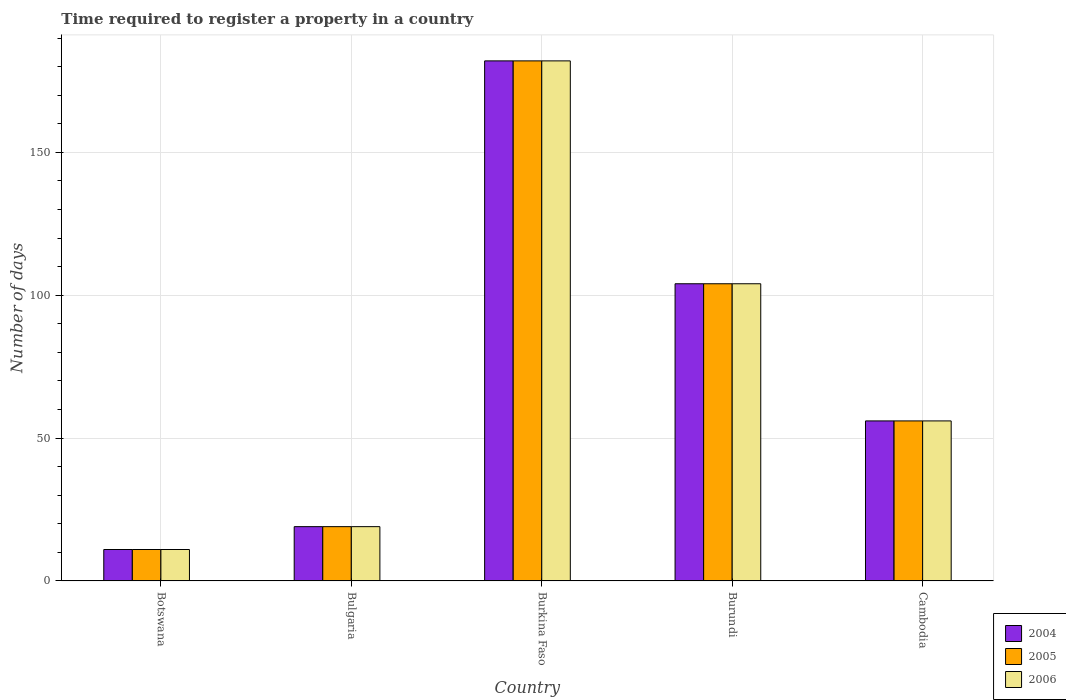Are the number of bars per tick equal to the number of legend labels?
Your response must be concise. Yes. How many bars are there on the 5th tick from the left?
Keep it short and to the point. 3. How many bars are there on the 5th tick from the right?
Ensure brevity in your answer.  3. In how many cases, is the number of bars for a given country not equal to the number of legend labels?
Your answer should be compact. 0. Across all countries, what is the maximum number of days required to register a property in 2004?
Offer a terse response. 182. Across all countries, what is the minimum number of days required to register a property in 2005?
Give a very brief answer. 11. In which country was the number of days required to register a property in 2006 maximum?
Provide a short and direct response. Burkina Faso. In which country was the number of days required to register a property in 2004 minimum?
Ensure brevity in your answer.  Botswana. What is the total number of days required to register a property in 2005 in the graph?
Give a very brief answer. 372. What is the difference between the number of days required to register a property in 2005 in Botswana and that in Burkina Faso?
Provide a succinct answer. -171. What is the difference between the number of days required to register a property in 2006 in Burkina Faso and the number of days required to register a property in 2004 in Botswana?
Give a very brief answer. 171. What is the average number of days required to register a property in 2005 per country?
Provide a succinct answer. 74.4. What is the ratio of the number of days required to register a property in 2006 in Botswana to that in Burkina Faso?
Give a very brief answer. 0.06. Is the difference between the number of days required to register a property in 2005 in Burundi and Cambodia greater than the difference between the number of days required to register a property in 2004 in Burundi and Cambodia?
Your response must be concise. No. What is the difference between the highest and the second highest number of days required to register a property in 2006?
Offer a terse response. 48. What is the difference between the highest and the lowest number of days required to register a property in 2004?
Provide a short and direct response. 171. In how many countries, is the number of days required to register a property in 2006 greater than the average number of days required to register a property in 2006 taken over all countries?
Keep it short and to the point. 2. What does the 3rd bar from the left in Botswana represents?
Keep it short and to the point. 2006. How many bars are there?
Offer a very short reply. 15. How many countries are there in the graph?
Give a very brief answer. 5. What is the difference between two consecutive major ticks on the Y-axis?
Your response must be concise. 50. Are the values on the major ticks of Y-axis written in scientific E-notation?
Offer a terse response. No. Does the graph contain any zero values?
Your response must be concise. No. Where does the legend appear in the graph?
Offer a terse response. Bottom right. How are the legend labels stacked?
Provide a succinct answer. Vertical. What is the title of the graph?
Keep it short and to the point. Time required to register a property in a country. Does "1975" appear as one of the legend labels in the graph?
Make the answer very short. No. What is the label or title of the X-axis?
Make the answer very short. Country. What is the label or title of the Y-axis?
Offer a terse response. Number of days. What is the Number of days of 2004 in Botswana?
Your answer should be compact. 11. What is the Number of days in 2006 in Botswana?
Provide a short and direct response. 11. What is the Number of days of 2004 in Bulgaria?
Provide a short and direct response. 19. What is the Number of days of 2005 in Bulgaria?
Make the answer very short. 19. What is the Number of days in 2004 in Burkina Faso?
Ensure brevity in your answer.  182. What is the Number of days of 2005 in Burkina Faso?
Keep it short and to the point. 182. What is the Number of days of 2006 in Burkina Faso?
Offer a very short reply. 182. What is the Number of days in 2004 in Burundi?
Provide a succinct answer. 104. What is the Number of days of 2005 in Burundi?
Offer a terse response. 104. What is the Number of days in 2006 in Burundi?
Your answer should be compact. 104. What is the Number of days of 2005 in Cambodia?
Keep it short and to the point. 56. What is the Number of days in 2006 in Cambodia?
Your answer should be very brief. 56. Across all countries, what is the maximum Number of days in 2004?
Keep it short and to the point. 182. Across all countries, what is the maximum Number of days in 2005?
Provide a short and direct response. 182. Across all countries, what is the maximum Number of days of 2006?
Your response must be concise. 182. Across all countries, what is the minimum Number of days in 2004?
Give a very brief answer. 11. Across all countries, what is the minimum Number of days in 2006?
Provide a short and direct response. 11. What is the total Number of days of 2004 in the graph?
Offer a very short reply. 372. What is the total Number of days in 2005 in the graph?
Provide a succinct answer. 372. What is the total Number of days of 2006 in the graph?
Make the answer very short. 372. What is the difference between the Number of days in 2004 in Botswana and that in Bulgaria?
Provide a succinct answer. -8. What is the difference between the Number of days of 2005 in Botswana and that in Bulgaria?
Your answer should be very brief. -8. What is the difference between the Number of days in 2006 in Botswana and that in Bulgaria?
Your answer should be very brief. -8. What is the difference between the Number of days in 2004 in Botswana and that in Burkina Faso?
Make the answer very short. -171. What is the difference between the Number of days in 2005 in Botswana and that in Burkina Faso?
Your response must be concise. -171. What is the difference between the Number of days of 2006 in Botswana and that in Burkina Faso?
Your response must be concise. -171. What is the difference between the Number of days of 2004 in Botswana and that in Burundi?
Offer a very short reply. -93. What is the difference between the Number of days in 2005 in Botswana and that in Burundi?
Your answer should be compact. -93. What is the difference between the Number of days of 2006 in Botswana and that in Burundi?
Offer a terse response. -93. What is the difference between the Number of days of 2004 in Botswana and that in Cambodia?
Offer a terse response. -45. What is the difference between the Number of days of 2005 in Botswana and that in Cambodia?
Your response must be concise. -45. What is the difference between the Number of days in 2006 in Botswana and that in Cambodia?
Provide a succinct answer. -45. What is the difference between the Number of days in 2004 in Bulgaria and that in Burkina Faso?
Ensure brevity in your answer.  -163. What is the difference between the Number of days of 2005 in Bulgaria and that in Burkina Faso?
Your answer should be very brief. -163. What is the difference between the Number of days of 2006 in Bulgaria and that in Burkina Faso?
Ensure brevity in your answer.  -163. What is the difference between the Number of days in 2004 in Bulgaria and that in Burundi?
Provide a short and direct response. -85. What is the difference between the Number of days of 2005 in Bulgaria and that in Burundi?
Your answer should be compact. -85. What is the difference between the Number of days of 2006 in Bulgaria and that in Burundi?
Keep it short and to the point. -85. What is the difference between the Number of days of 2004 in Bulgaria and that in Cambodia?
Your answer should be very brief. -37. What is the difference between the Number of days of 2005 in Bulgaria and that in Cambodia?
Offer a very short reply. -37. What is the difference between the Number of days of 2006 in Bulgaria and that in Cambodia?
Give a very brief answer. -37. What is the difference between the Number of days of 2004 in Burkina Faso and that in Burundi?
Keep it short and to the point. 78. What is the difference between the Number of days in 2005 in Burkina Faso and that in Burundi?
Your response must be concise. 78. What is the difference between the Number of days in 2004 in Burkina Faso and that in Cambodia?
Offer a very short reply. 126. What is the difference between the Number of days of 2005 in Burkina Faso and that in Cambodia?
Keep it short and to the point. 126. What is the difference between the Number of days of 2006 in Burkina Faso and that in Cambodia?
Provide a succinct answer. 126. What is the difference between the Number of days in 2005 in Burundi and that in Cambodia?
Offer a terse response. 48. What is the difference between the Number of days of 2004 in Botswana and the Number of days of 2006 in Bulgaria?
Ensure brevity in your answer.  -8. What is the difference between the Number of days of 2005 in Botswana and the Number of days of 2006 in Bulgaria?
Keep it short and to the point. -8. What is the difference between the Number of days in 2004 in Botswana and the Number of days in 2005 in Burkina Faso?
Offer a terse response. -171. What is the difference between the Number of days in 2004 in Botswana and the Number of days in 2006 in Burkina Faso?
Your response must be concise. -171. What is the difference between the Number of days of 2005 in Botswana and the Number of days of 2006 in Burkina Faso?
Offer a terse response. -171. What is the difference between the Number of days in 2004 in Botswana and the Number of days in 2005 in Burundi?
Your answer should be very brief. -93. What is the difference between the Number of days in 2004 in Botswana and the Number of days in 2006 in Burundi?
Give a very brief answer. -93. What is the difference between the Number of days of 2005 in Botswana and the Number of days of 2006 in Burundi?
Give a very brief answer. -93. What is the difference between the Number of days of 2004 in Botswana and the Number of days of 2005 in Cambodia?
Keep it short and to the point. -45. What is the difference between the Number of days in 2004 in Botswana and the Number of days in 2006 in Cambodia?
Your response must be concise. -45. What is the difference between the Number of days in 2005 in Botswana and the Number of days in 2006 in Cambodia?
Your answer should be compact. -45. What is the difference between the Number of days in 2004 in Bulgaria and the Number of days in 2005 in Burkina Faso?
Ensure brevity in your answer.  -163. What is the difference between the Number of days in 2004 in Bulgaria and the Number of days in 2006 in Burkina Faso?
Give a very brief answer. -163. What is the difference between the Number of days of 2005 in Bulgaria and the Number of days of 2006 in Burkina Faso?
Offer a very short reply. -163. What is the difference between the Number of days of 2004 in Bulgaria and the Number of days of 2005 in Burundi?
Provide a short and direct response. -85. What is the difference between the Number of days in 2004 in Bulgaria and the Number of days in 2006 in Burundi?
Your answer should be very brief. -85. What is the difference between the Number of days in 2005 in Bulgaria and the Number of days in 2006 in Burundi?
Make the answer very short. -85. What is the difference between the Number of days of 2004 in Bulgaria and the Number of days of 2005 in Cambodia?
Your answer should be compact. -37. What is the difference between the Number of days of 2004 in Bulgaria and the Number of days of 2006 in Cambodia?
Provide a succinct answer. -37. What is the difference between the Number of days of 2005 in Bulgaria and the Number of days of 2006 in Cambodia?
Provide a short and direct response. -37. What is the difference between the Number of days of 2004 in Burkina Faso and the Number of days of 2006 in Burundi?
Provide a succinct answer. 78. What is the difference between the Number of days of 2004 in Burkina Faso and the Number of days of 2005 in Cambodia?
Offer a very short reply. 126. What is the difference between the Number of days in 2004 in Burkina Faso and the Number of days in 2006 in Cambodia?
Give a very brief answer. 126. What is the difference between the Number of days of 2005 in Burkina Faso and the Number of days of 2006 in Cambodia?
Provide a succinct answer. 126. What is the difference between the Number of days of 2005 in Burundi and the Number of days of 2006 in Cambodia?
Offer a very short reply. 48. What is the average Number of days of 2004 per country?
Provide a succinct answer. 74.4. What is the average Number of days in 2005 per country?
Your answer should be compact. 74.4. What is the average Number of days of 2006 per country?
Provide a short and direct response. 74.4. What is the difference between the Number of days of 2004 and Number of days of 2005 in Botswana?
Provide a short and direct response. 0. What is the difference between the Number of days in 2005 and Number of days in 2006 in Botswana?
Your answer should be very brief. 0. What is the difference between the Number of days of 2004 and Number of days of 2005 in Bulgaria?
Your answer should be very brief. 0. What is the difference between the Number of days of 2004 and Number of days of 2006 in Bulgaria?
Offer a terse response. 0. What is the difference between the Number of days of 2004 and Number of days of 2005 in Burkina Faso?
Offer a very short reply. 0. What is the difference between the Number of days of 2004 and Number of days of 2006 in Burkina Faso?
Make the answer very short. 0. What is the difference between the Number of days in 2005 and Number of days in 2006 in Burkina Faso?
Offer a very short reply. 0. What is the difference between the Number of days of 2004 and Number of days of 2005 in Burundi?
Provide a succinct answer. 0. What is the difference between the Number of days in 2004 and Number of days in 2006 in Burundi?
Offer a terse response. 0. What is the difference between the Number of days in 2005 and Number of days in 2006 in Burundi?
Provide a short and direct response. 0. What is the difference between the Number of days in 2004 and Number of days in 2006 in Cambodia?
Ensure brevity in your answer.  0. What is the difference between the Number of days of 2005 and Number of days of 2006 in Cambodia?
Provide a short and direct response. 0. What is the ratio of the Number of days of 2004 in Botswana to that in Bulgaria?
Provide a short and direct response. 0.58. What is the ratio of the Number of days in 2005 in Botswana to that in Bulgaria?
Provide a succinct answer. 0.58. What is the ratio of the Number of days of 2006 in Botswana to that in Bulgaria?
Offer a terse response. 0.58. What is the ratio of the Number of days of 2004 in Botswana to that in Burkina Faso?
Give a very brief answer. 0.06. What is the ratio of the Number of days in 2005 in Botswana to that in Burkina Faso?
Ensure brevity in your answer.  0.06. What is the ratio of the Number of days in 2006 in Botswana to that in Burkina Faso?
Offer a terse response. 0.06. What is the ratio of the Number of days in 2004 in Botswana to that in Burundi?
Give a very brief answer. 0.11. What is the ratio of the Number of days in 2005 in Botswana to that in Burundi?
Provide a short and direct response. 0.11. What is the ratio of the Number of days of 2006 in Botswana to that in Burundi?
Offer a terse response. 0.11. What is the ratio of the Number of days in 2004 in Botswana to that in Cambodia?
Make the answer very short. 0.2. What is the ratio of the Number of days in 2005 in Botswana to that in Cambodia?
Ensure brevity in your answer.  0.2. What is the ratio of the Number of days of 2006 in Botswana to that in Cambodia?
Make the answer very short. 0.2. What is the ratio of the Number of days of 2004 in Bulgaria to that in Burkina Faso?
Your answer should be very brief. 0.1. What is the ratio of the Number of days of 2005 in Bulgaria to that in Burkina Faso?
Ensure brevity in your answer.  0.1. What is the ratio of the Number of days of 2006 in Bulgaria to that in Burkina Faso?
Ensure brevity in your answer.  0.1. What is the ratio of the Number of days of 2004 in Bulgaria to that in Burundi?
Provide a short and direct response. 0.18. What is the ratio of the Number of days in 2005 in Bulgaria to that in Burundi?
Offer a very short reply. 0.18. What is the ratio of the Number of days in 2006 in Bulgaria to that in Burundi?
Ensure brevity in your answer.  0.18. What is the ratio of the Number of days in 2004 in Bulgaria to that in Cambodia?
Make the answer very short. 0.34. What is the ratio of the Number of days in 2005 in Bulgaria to that in Cambodia?
Keep it short and to the point. 0.34. What is the ratio of the Number of days of 2006 in Bulgaria to that in Cambodia?
Your answer should be compact. 0.34. What is the ratio of the Number of days in 2004 in Burkina Faso to that in Burundi?
Your response must be concise. 1.75. What is the ratio of the Number of days in 2004 in Burundi to that in Cambodia?
Provide a short and direct response. 1.86. What is the ratio of the Number of days of 2005 in Burundi to that in Cambodia?
Provide a succinct answer. 1.86. What is the ratio of the Number of days in 2006 in Burundi to that in Cambodia?
Your answer should be compact. 1.86. What is the difference between the highest and the second highest Number of days in 2005?
Give a very brief answer. 78. What is the difference between the highest and the lowest Number of days of 2004?
Provide a succinct answer. 171. What is the difference between the highest and the lowest Number of days in 2005?
Offer a terse response. 171. What is the difference between the highest and the lowest Number of days of 2006?
Give a very brief answer. 171. 